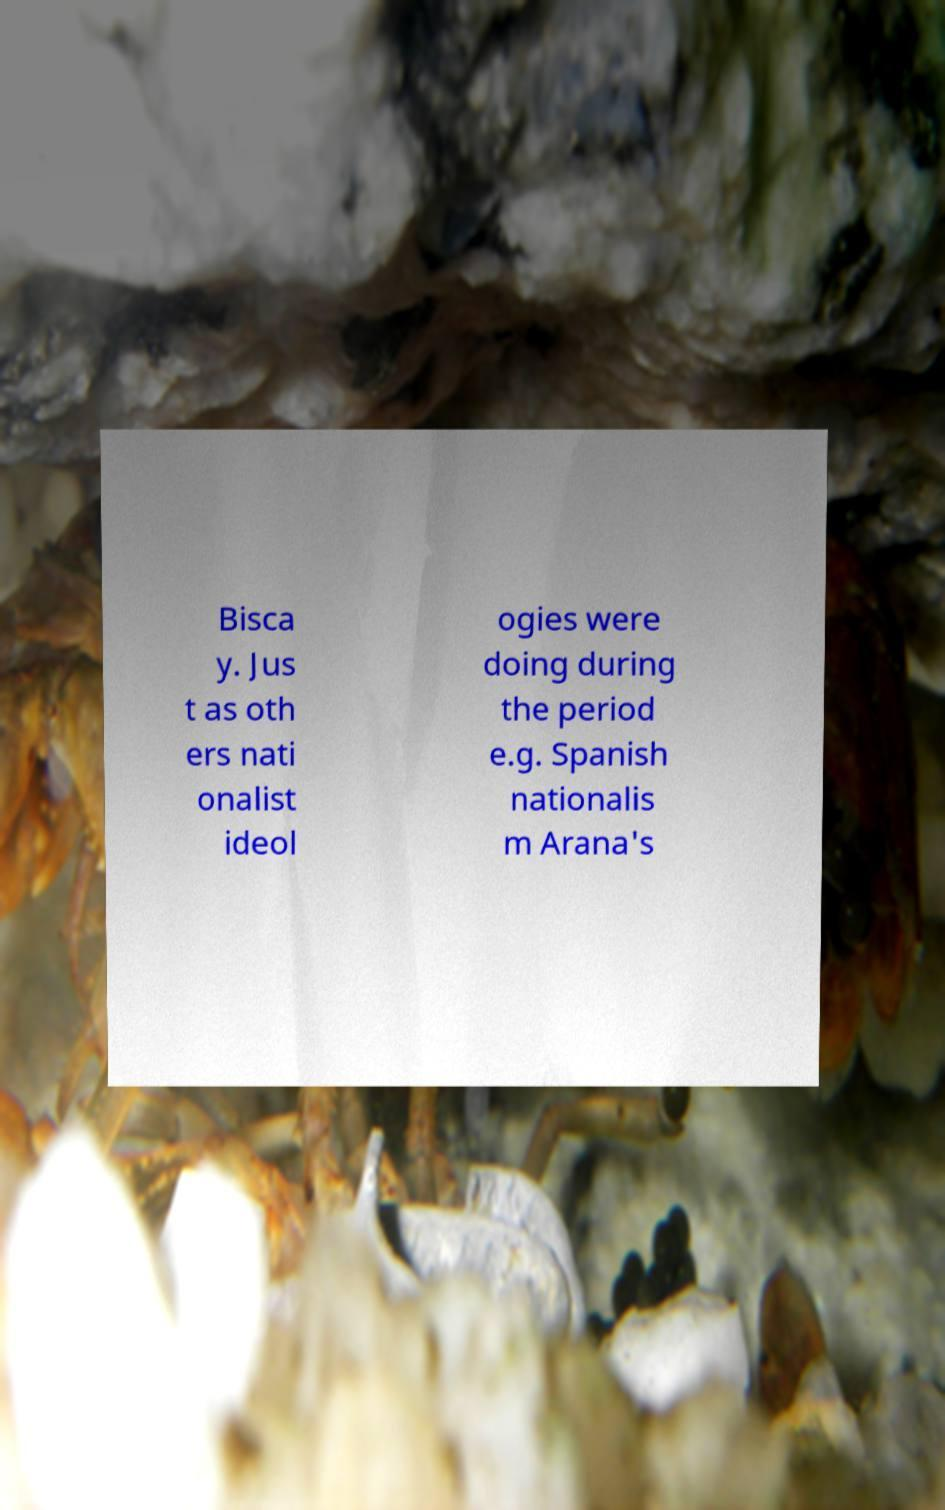For documentation purposes, I need the text within this image transcribed. Could you provide that? Bisca y. Jus t as oth ers nati onalist ideol ogies were doing during the period e.g. Spanish nationalis m Arana's 